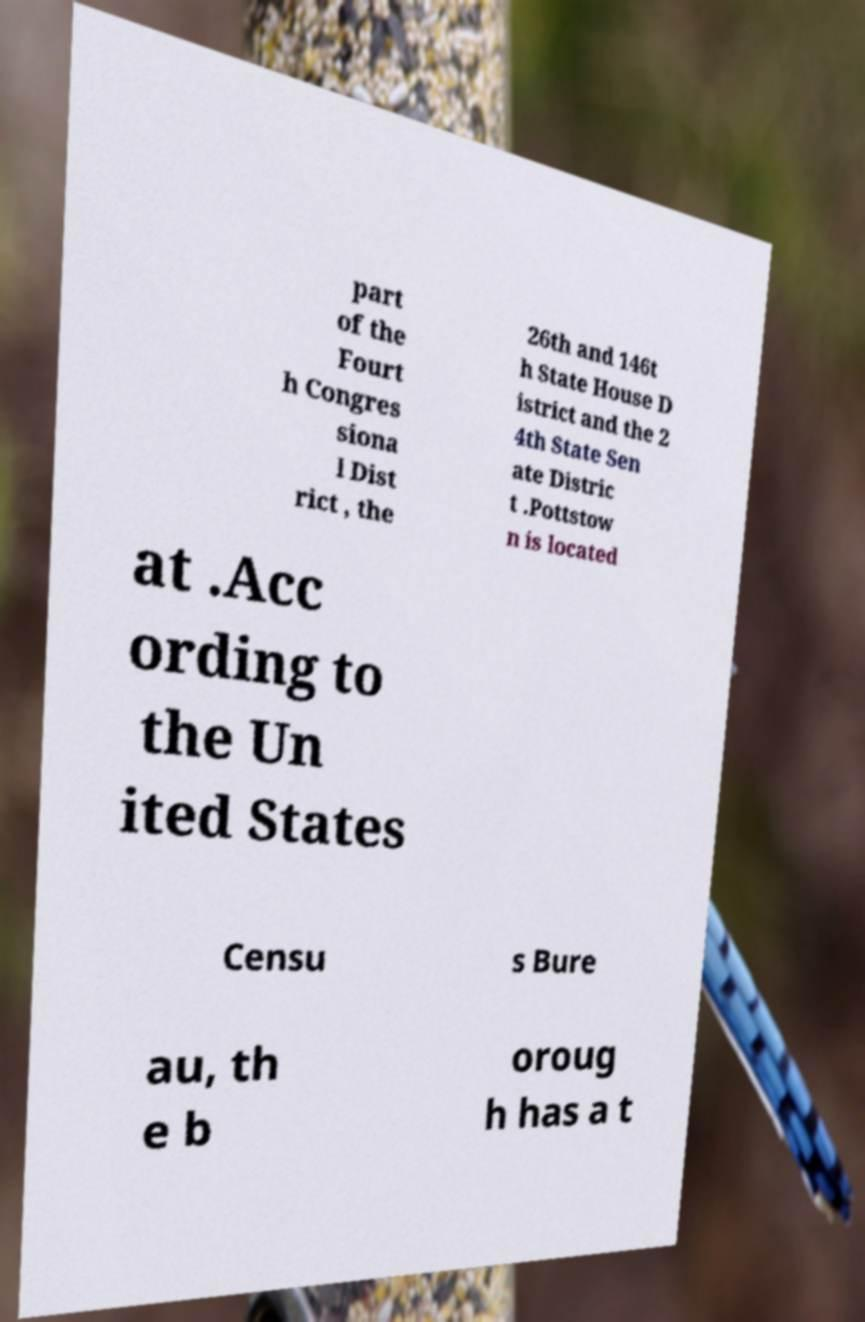Can you read and provide the text displayed in the image?This photo seems to have some interesting text. Can you extract and type it out for me? part of the Fourt h Congres siona l Dist rict , the 26th and 146t h State House D istrict and the 2 4th State Sen ate Distric t .Pottstow n is located at .Acc ording to the Un ited States Censu s Bure au, th e b oroug h has a t 